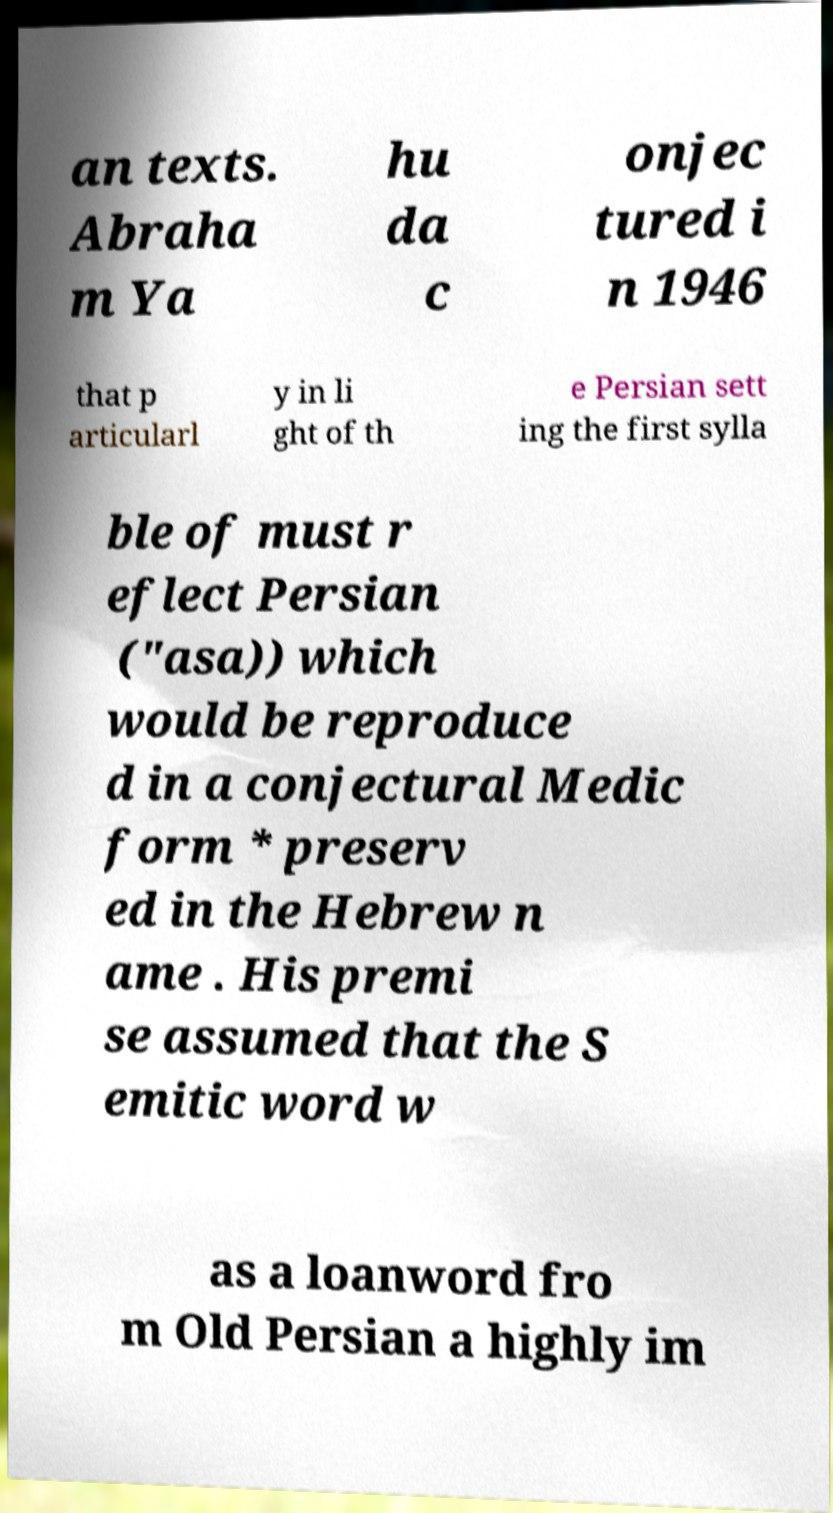For documentation purposes, I need the text within this image transcribed. Could you provide that? an texts. Abraha m Ya hu da c onjec tured i n 1946 that p articularl y in li ght of th e Persian sett ing the first sylla ble of must r eflect Persian ("asa)) which would be reproduce d in a conjectural Medic form * preserv ed in the Hebrew n ame . His premi se assumed that the S emitic word w as a loanword fro m Old Persian a highly im 